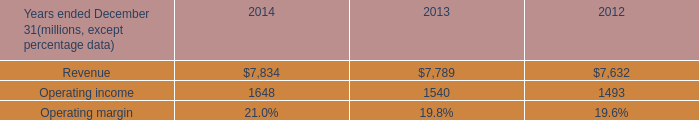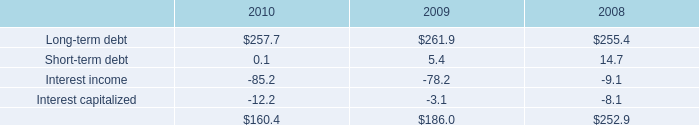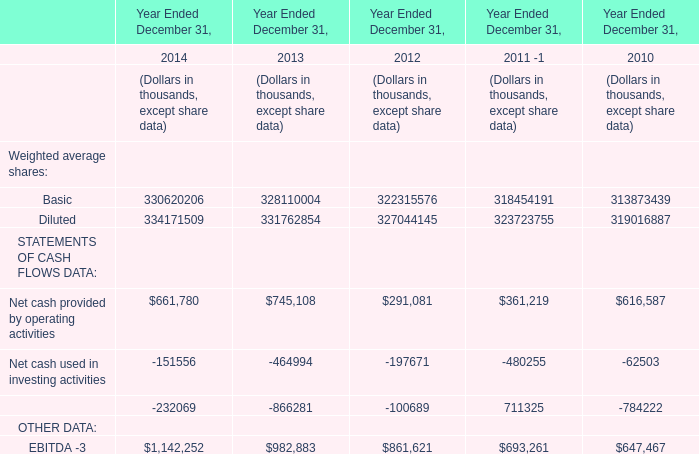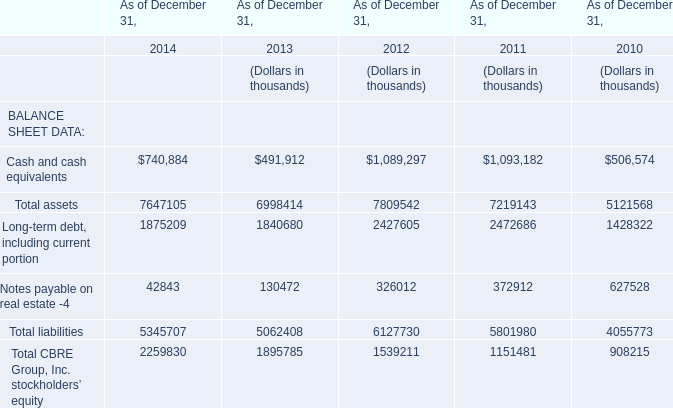What is the sum of Net cash provided by operating activitiesNet cash used in investing activitiesNet cash (used in) provided by financing activities in 2014? (in thousand) 
Computations: ((661780 - 151556) - 232069)
Answer: 278155.0. 